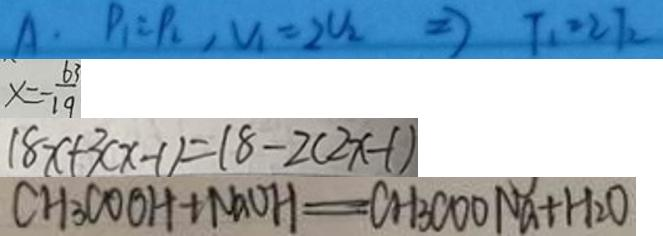<formula> <loc_0><loc_0><loc_500><loc_500>A \cdot P _ { 1 } = P _ { 2 } , V _ { 1 } = 2 U _ { 2 } \Rightarrow T _ { 1 } = 2 T _ { 2 } 
 x = - \frac { 6 3 } { 1 9 } 
 1 8 x + 3 ( x - 1 ) = 1 8 - 2 ( 2 x - 1 ) 
 C H _ { 3 } C O O H + N a O H = C H _ { 3 } C O O N a + H _ { 2 } O</formula> 